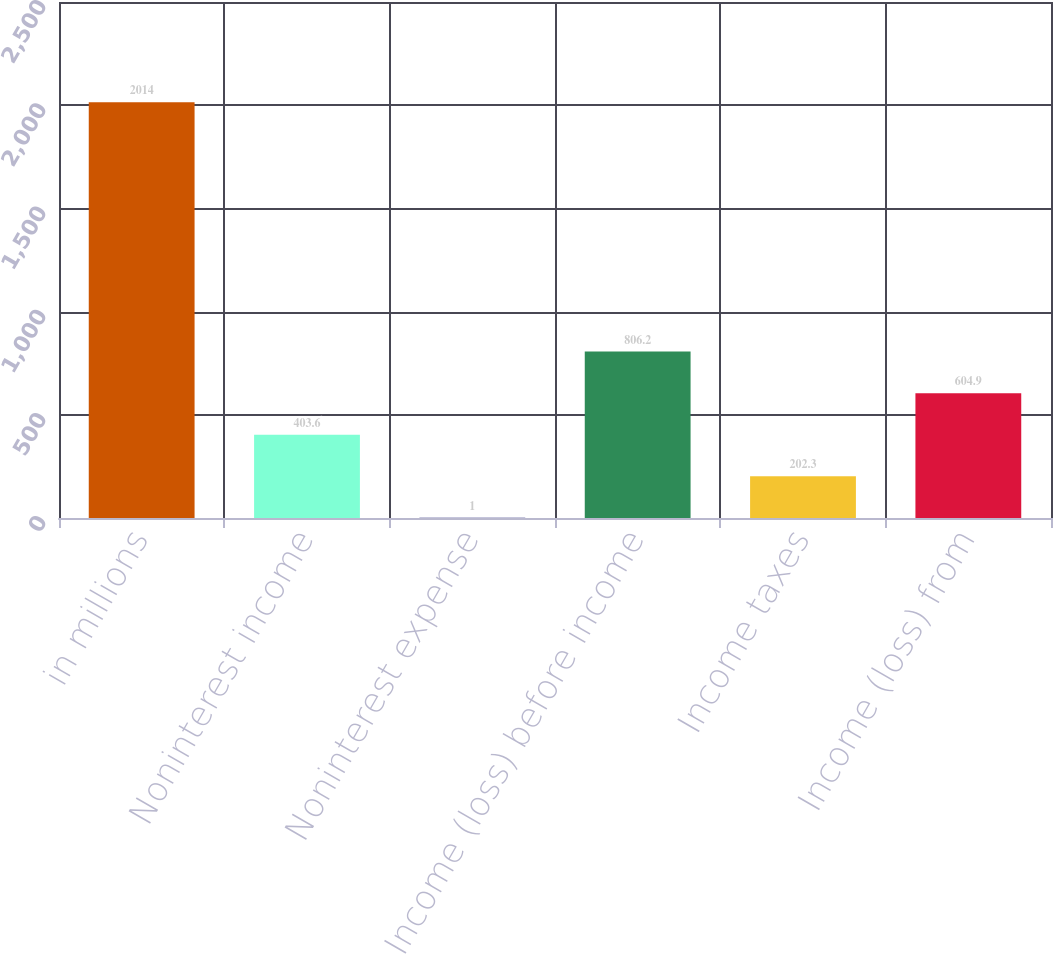Convert chart. <chart><loc_0><loc_0><loc_500><loc_500><bar_chart><fcel>in millions<fcel>Noninterest income<fcel>Noninterest expense<fcel>Income (loss) before income<fcel>Income taxes<fcel>Income (loss) from<nl><fcel>2014<fcel>403.6<fcel>1<fcel>806.2<fcel>202.3<fcel>604.9<nl></chart> 